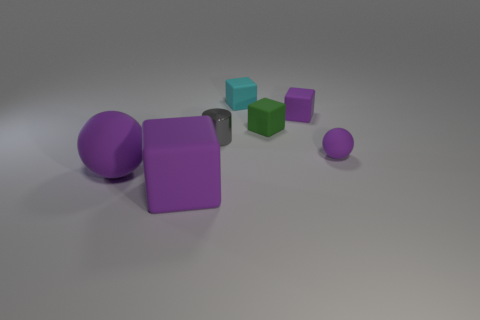Add 2 small red cubes. How many objects exist? 9 Subtract all cylinders. How many objects are left? 6 Add 5 tiny red spheres. How many tiny red spheres exist? 5 Subtract 0 yellow blocks. How many objects are left? 7 Subtract all spheres. Subtract all big rubber objects. How many objects are left? 3 Add 4 small cyan rubber things. How many small cyan rubber things are left? 5 